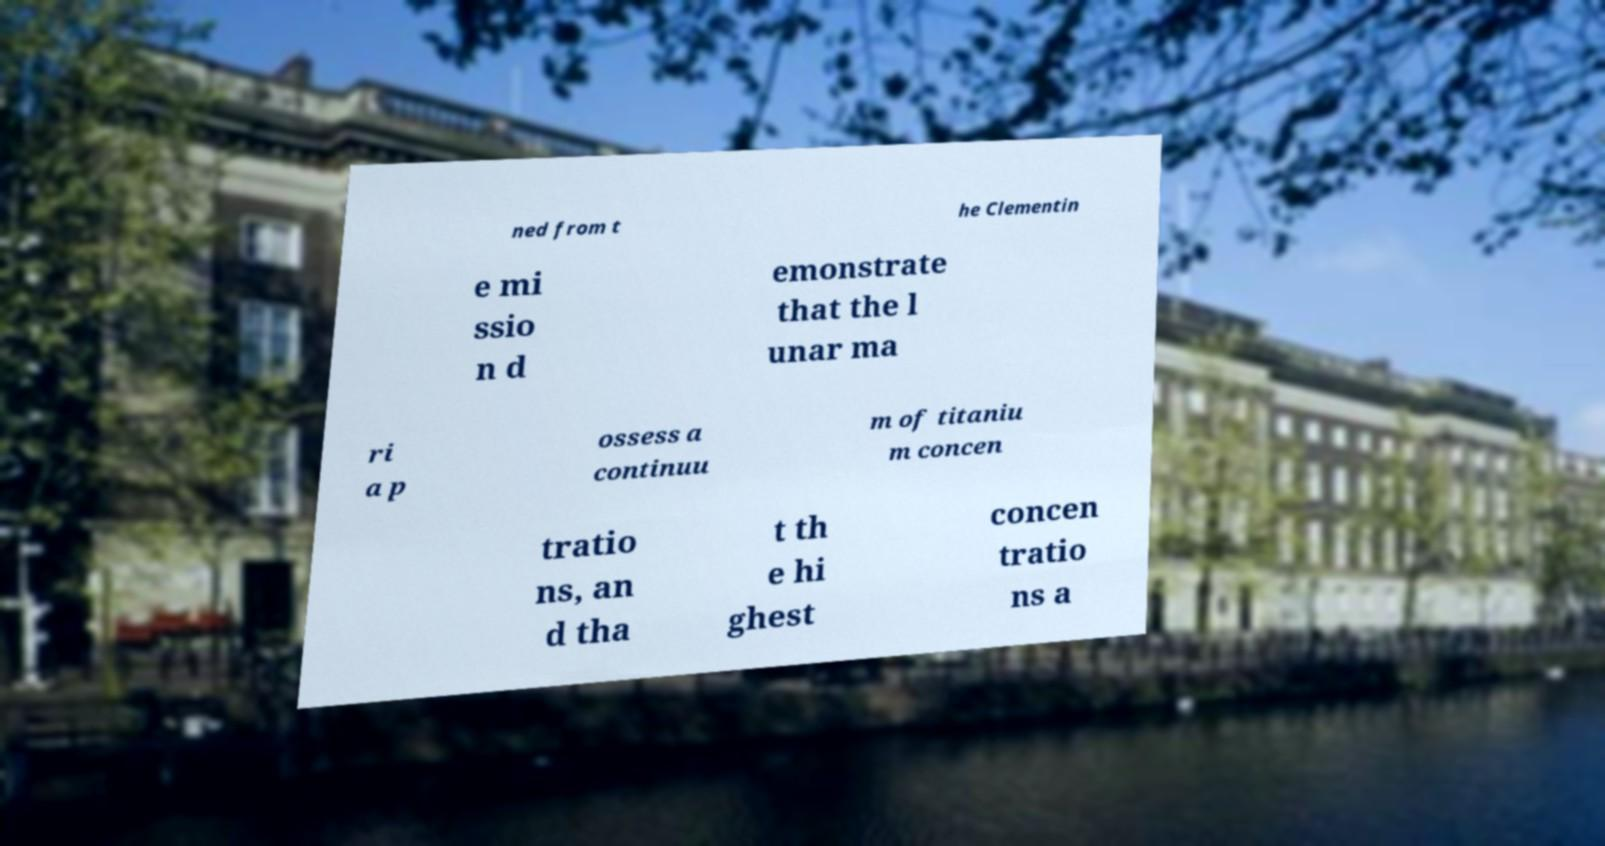There's text embedded in this image that I need extracted. Can you transcribe it verbatim? ned from t he Clementin e mi ssio n d emonstrate that the l unar ma ri a p ossess a continuu m of titaniu m concen tratio ns, an d tha t th e hi ghest concen tratio ns a 